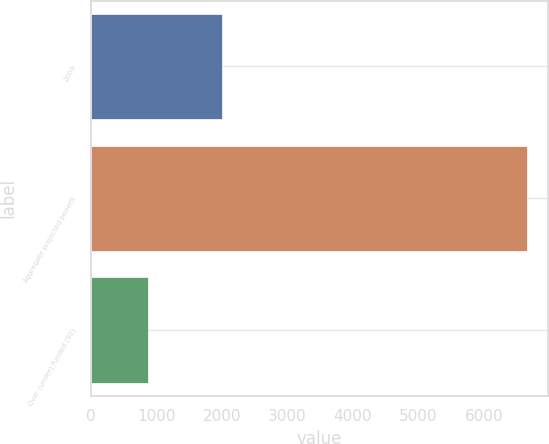Convert chart. <chart><loc_0><loc_0><loc_500><loc_500><bar_chart><fcel>2009<fcel>Aggregate projected benefit<fcel>Over (under) funded (92)<nl><fcel>2009<fcel>6649<fcel>879<nl></chart> 